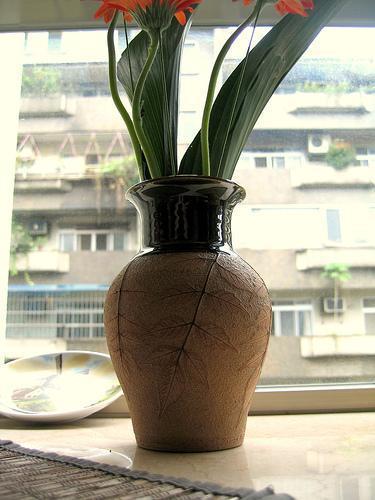How many vases are there?
Give a very brief answer. 1. 